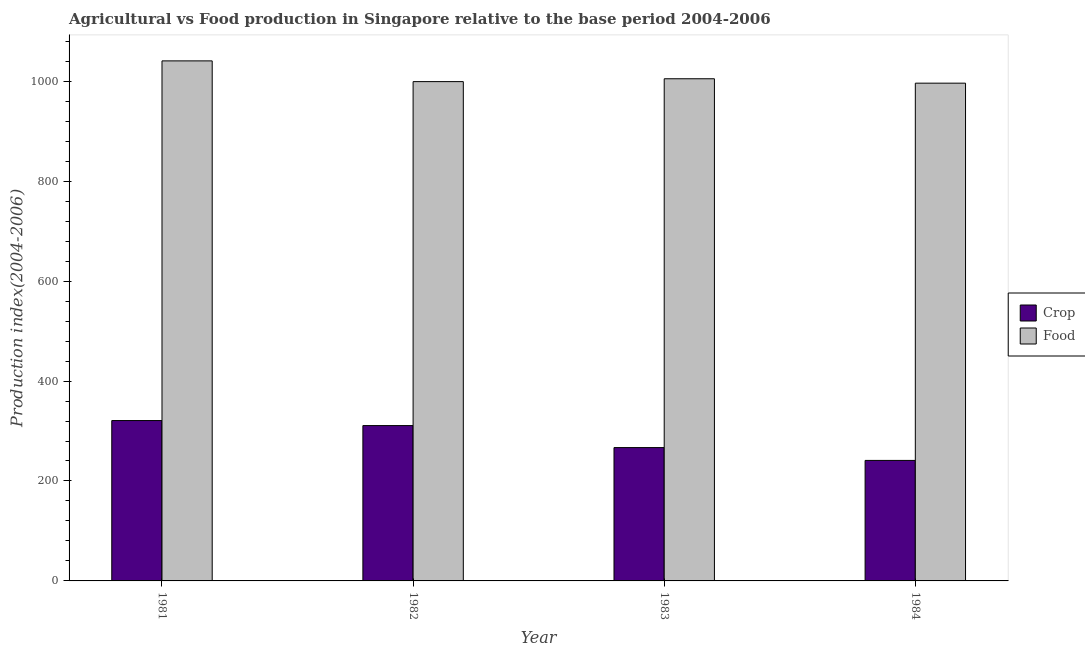How many bars are there on the 3rd tick from the left?
Keep it short and to the point. 2. In how many cases, is the number of bars for a given year not equal to the number of legend labels?
Your answer should be very brief. 0. What is the crop production index in 1981?
Provide a short and direct response. 320.93. Across all years, what is the maximum food production index?
Make the answer very short. 1040.77. Across all years, what is the minimum food production index?
Your answer should be compact. 996.16. What is the total crop production index in the graph?
Your answer should be very brief. 1139.82. What is the difference between the crop production index in 1982 and that in 1984?
Provide a short and direct response. 69.71. What is the difference between the food production index in 1982 and the crop production index in 1983?
Provide a short and direct response. -5.73. What is the average food production index per year?
Provide a short and direct response. 1010.3. In the year 1982, what is the difference between the food production index and crop production index?
Provide a short and direct response. 0. In how many years, is the crop production index greater than 760?
Provide a short and direct response. 0. What is the ratio of the crop production index in 1982 to that in 1984?
Offer a terse response. 1.29. Is the crop production index in 1982 less than that in 1984?
Your answer should be very brief. No. Is the difference between the crop production index in 1982 and 1983 greater than the difference between the food production index in 1982 and 1983?
Offer a terse response. No. What is the difference between the highest and the second highest food production index?
Make the answer very short. 35.77. What is the difference between the highest and the lowest crop production index?
Ensure brevity in your answer.  79.76. In how many years, is the food production index greater than the average food production index taken over all years?
Give a very brief answer. 1. What does the 2nd bar from the left in 1981 represents?
Offer a very short reply. Food. What does the 2nd bar from the right in 1984 represents?
Your answer should be compact. Crop. Are all the bars in the graph horizontal?
Provide a succinct answer. No. What is the difference between two consecutive major ticks on the Y-axis?
Your answer should be compact. 200. Are the values on the major ticks of Y-axis written in scientific E-notation?
Your response must be concise. No. Does the graph contain grids?
Offer a terse response. No. Where does the legend appear in the graph?
Your answer should be very brief. Center right. How many legend labels are there?
Your response must be concise. 2. What is the title of the graph?
Make the answer very short. Agricultural vs Food production in Singapore relative to the base period 2004-2006. What is the label or title of the Y-axis?
Provide a succinct answer. Production index(2004-2006). What is the Production index(2004-2006) of Crop in 1981?
Your answer should be very brief. 320.93. What is the Production index(2004-2006) in Food in 1981?
Make the answer very short. 1040.77. What is the Production index(2004-2006) of Crop in 1982?
Provide a short and direct response. 310.88. What is the Production index(2004-2006) in Food in 1982?
Your answer should be very brief. 999.27. What is the Production index(2004-2006) of Crop in 1983?
Your response must be concise. 266.84. What is the Production index(2004-2006) in Food in 1983?
Ensure brevity in your answer.  1005. What is the Production index(2004-2006) in Crop in 1984?
Provide a succinct answer. 241.17. What is the Production index(2004-2006) in Food in 1984?
Ensure brevity in your answer.  996.16. Across all years, what is the maximum Production index(2004-2006) in Crop?
Your answer should be very brief. 320.93. Across all years, what is the maximum Production index(2004-2006) of Food?
Give a very brief answer. 1040.77. Across all years, what is the minimum Production index(2004-2006) in Crop?
Your answer should be compact. 241.17. Across all years, what is the minimum Production index(2004-2006) of Food?
Give a very brief answer. 996.16. What is the total Production index(2004-2006) in Crop in the graph?
Your answer should be very brief. 1139.82. What is the total Production index(2004-2006) of Food in the graph?
Offer a terse response. 4041.2. What is the difference between the Production index(2004-2006) of Crop in 1981 and that in 1982?
Provide a succinct answer. 10.05. What is the difference between the Production index(2004-2006) in Food in 1981 and that in 1982?
Your answer should be very brief. 41.5. What is the difference between the Production index(2004-2006) of Crop in 1981 and that in 1983?
Offer a terse response. 54.09. What is the difference between the Production index(2004-2006) of Food in 1981 and that in 1983?
Provide a succinct answer. 35.77. What is the difference between the Production index(2004-2006) of Crop in 1981 and that in 1984?
Keep it short and to the point. 79.76. What is the difference between the Production index(2004-2006) of Food in 1981 and that in 1984?
Provide a short and direct response. 44.61. What is the difference between the Production index(2004-2006) of Crop in 1982 and that in 1983?
Provide a short and direct response. 44.04. What is the difference between the Production index(2004-2006) in Food in 1982 and that in 1983?
Keep it short and to the point. -5.73. What is the difference between the Production index(2004-2006) of Crop in 1982 and that in 1984?
Provide a succinct answer. 69.71. What is the difference between the Production index(2004-2006) of Food in 1982 and that in 1984?
Provide a short and direct response. 3.11. What is the difference between the Production index(2004-2006) in Crop in 1983 and that in 1984?
Your answer should be compact. 25.67. What is the difference between the Production index(2004-2006) in Food in 1983 and that in 1984?
Provide a succinct answer. 8.84. What is the difference between the Production index(2004-2006) in Crop in 1981 and the Production index(2004-2006) in Food in 1982?
Offer a very short reply. -678.34. What is the difference between the Production index(2004-2006) of Crop in 1981 and the Production index(2004-2006) of Food in 1983?
Your answer should be very brief. -684.07. What is the difference between the Production index(2004-2006) of Crop in 1981 and the Production index(2004-2006) of Food in 1984?
Provide a short and direct response. -675.23. What is the difference between the Production index(2004-2006) in Crop in 1982 and the Production index(2004-2006) in Food in 1983?
Your response must be concise. -694.12. What is the difference between the Production index(2004-2006) of Crop in 1982 and the Production index(2004-2006) of Food in 1984?
Keep it short and to the point. -685.28. What is the difference between the Production index(2004-2006) of Crop in 1983 and the Production index(2004-2006) of Food in 1984?
Offer a terse response. -729.32. What is the average Production index(2004-2006) in Crop per year?
Offer a terse response. 284.95. What is the average Production index(2004-2006) of Food per year?
Ensure brevity in your answer.  1010.3. In the year 1981, what is the difference between the Production index(2004-2006) in Crop and Production index(2004-2006) in Food?
Ensure brevity in your answer.  -719.84. In the year 1982, what is the difference between the Production index(2004-2006) in Crop and Production index(2004-2006) in Food?
Your answer should be compact. -688.39. In the year 1983, what is the difference between the Production index(2004-2006) in Crop and Production index(2004-2006) in Food?
Offer a terse response. -738.16. In the year 1984, what is the difference between the Production index(2004-2006) in Crop and Production index(2004-2006) in Food?
Make the answer very short. -754.99. What is the ratio of the Production index(2004-2006) in Crop in 1981 to that in 1982?
Provide a succinct answer. 1.03. What is the ratio of the Production index(2004-2006) of Food in 1981 to that in 1982?
Provide a succinct answer. 1.04. What is the ratio of the Production index(2004-2006) in Crop in 1981 to that in 1983?
Make the answer very short. 1.2. What is the ratio of the Production index(2004-2006) of Food in 1981 to that in 1983?
Your answer should be very brief. 1.04. What is the ratio of the Production index(2004-2006) in Crop in 1981 to that in 1984?
Provide a succinct answer. 1.33. What is the ratio of the Production index(2004-2006) in Food in 1981 to that in 1984?
Give a very brief answer. 1.04. What is the ratio of the Production index(2004-2006) of Crop in 1982 to that in 1983?
Your response must be concise. 1.17. What is the ratio of the Production index(2004-2006) in Food in 1982 to that in 1983?
Ensure brevity in your answer.  0.99. What is the ratio of the Production index(2004-2006) of Crop in 1982 to that in 1984?
Keep it short and to the point. 1.29. What is the ratio of the Production index(2004-2006) of Crop in 1983 to that in 1984?
Provide a short and direct response. 1.11. What is the ratio of the Production index(2004-2006) in Food in 1983 to that in 1984?
Ensure brevity in your answer.  1.01. What is the difference between the highest and the second highest Production index(2004-2006) of Crop?
Give a very brief answer. 10.05. What is the difference between the highest and the second highest Production index(2004-2006) of Food?
Offer a very short reply. 35.77. What is the difference between the highest and the lowest Production index(2004-2006) of Crop?
Keep it short and to the point. 79.76. What is the difference between the highest and the lowest Production index(2004-2006) of Food?
Your answer should be very brief. 44.61. 